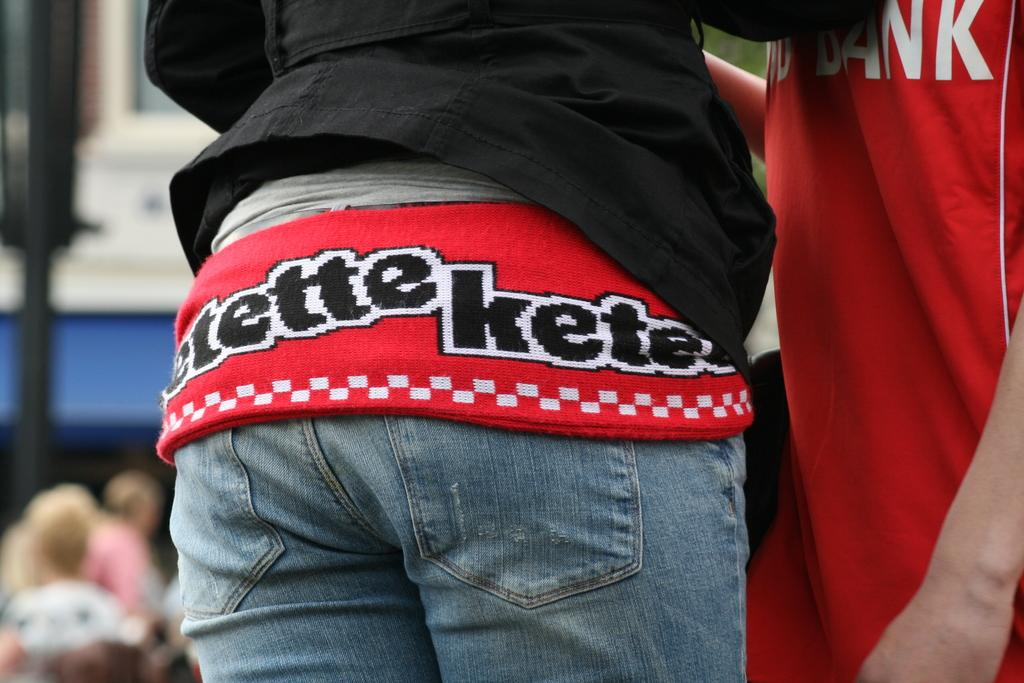<image>
Write a terse but informative summary of the picture. A persons sweater says Kete on the bottom of it. 